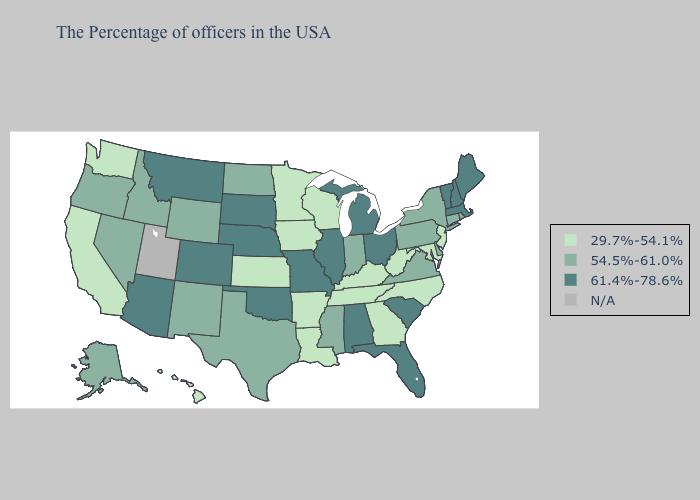What is the value of Utah?
Be succinct. N/A. Name the states that have a value in the range N/A?
Give a very brief answer. Utah. What is the value of Washington?
Give a very brief answer. 29.7%-54.1%. Does New York have the lowest value in the Northeast?
Give a very brief answer. No. What is the value of Nevada?
Be succinct. 54.5%-61.0%. Name the states that have a value in the range 29.7%-54.1%?
Keep it brief. New Jersey, Maryland, North Carolina, West Virginia, Georgia, Kentucky, Tennessee, Wisconsin, Louisiana, Arkansas, Minnesota, Iowa, Kansas, California, Washington, Hawaii. Is the legend a continuous bar?
Answer briefly. No. Name the states that have a value in the range 61.4%-78.6%?
Concise answer only. Maine, Massachusetts, New Hampshire, Vermont, South Carolina, Ohio, Florida, Michigan, Alabama, Illinois, Missouri, Nebraska, Oklahoma, South Dakota, Colorado, Montana, Arizona. What is the value of Arizona?
Keep it brief. 61.4%-78.6%. What is the value of Idaho?
Concise answer only. 54.5%-61.0%. Does Nebraska have the highest value in the USA?
Write a very short answer. Yes. Name the states that have a value in the range 29.7%-54.1%?
Quick response, please. New Jersey, Maryland, North Carolina, West Virginia, Georgia, Kentucky, Tennessee, Wisconsin, Louisiana, Arkansas, Minnesota, Iowa, Kansas, California, Washington, Hawaii. Which states have the highest value in the USA?
Answer briefly. Maine, Massachusetts, New Hampshire, Vermont, South Carolina, Ohio, Florida, Michigan, Alabama, Illinois, Missouri, Nebraska, Oklahoma, South Dakota, Colorado, Montana, Arizona. 